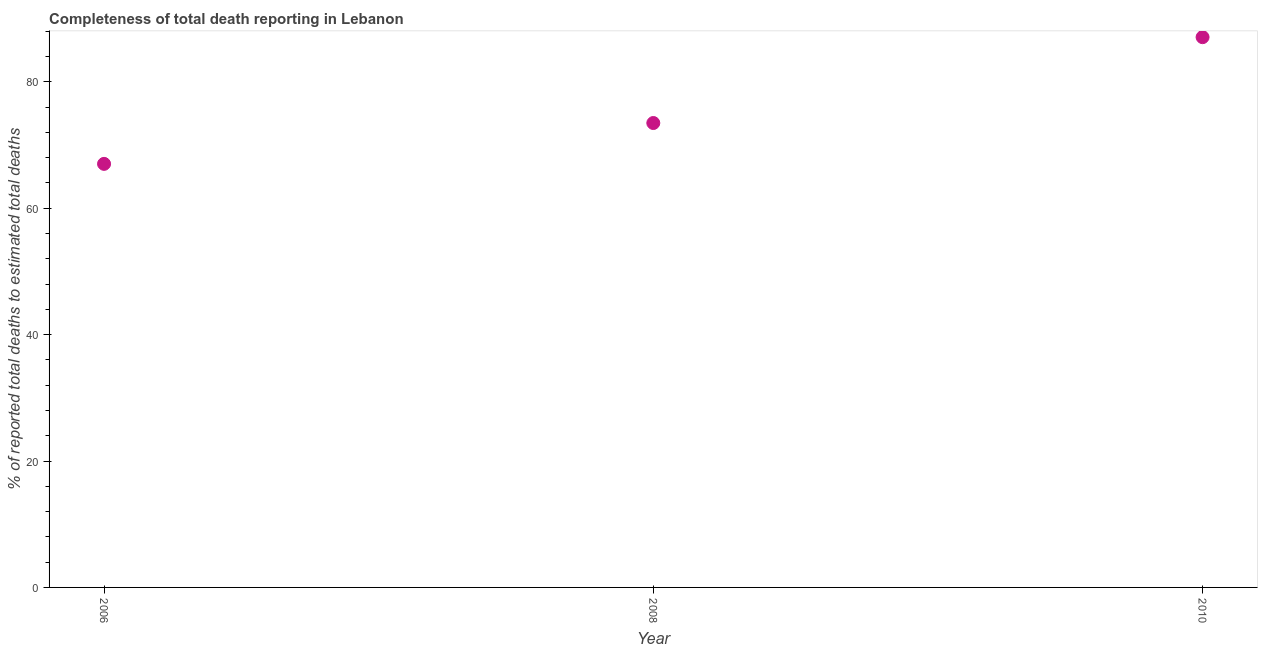What is the completeness of total death reports in 2010?
Provide a succinct answer. 87.08. Across all years, what is the maximum completeness of total death reports?
Offer a very short reply. 87.08. Across all years, what is the minimum completeness of total death reports?
Offer a terse response. 67.02. In which year was the completeness of total death reports maximum?
Make the answer very short. 2010. What is the sum of the completeness of total death reports?
Ensure brevity in your answer.  227.59. What is the difference between the completeness of total death reports in 2006 and 2010?
Provide a short and direct response. -20.05. What is the average completeness of total death reports per year?
Offer a terse response. 75.86. What is the median completeness of total death reports?
Keep it short and to the point. 73.49. In how many years, is the completeness of total death reports greater than 8 %?
Provide a succinct answer. 3. Do a majority of the years between 2006 and 2008 (inclusive) have completeness of total death reports greater than 40 %?
Offer a very short reply. Yes. What is the ratio of the completeness of total death reports in 2008 to that in 2010?
Ensure brevity in your answer.  0.84. Is the difference between the completeness of total death reports in 2008 and 2010 greater than the difference between any two years?
Give a very brief answer. No. What is the difference between the highest and the second highest completeness of total death reports?
Give a very brief answer. 13.59. Is the sum of the completeness of total death reports in 2006 and 2010 greater than the maximum completeness of total death reports across all years?
Offer a terse response. Yes. What is the difference between the highest and the lowest completeness of total death reports?
Ensure brevity in your answer.  20.05. Does the completeness of total death reports monotonically increase over the years?
Give a very brief answer. Yes. What is the difference between two consecutive major ticks on the Y-axis?
Provide a short and direct response. 20. Does the graph contain any zero values?
Give a very brief answer. No. What is the title of the graph?
Offer a terse response. Completeness of total death reporting in Lebanon. What is the label or title of the X-axis?
Your response must be concise. Year. What is the label or title of the Y-axis?
Keep it short and to the point. % of reported total deaths to estimated total deaths. What is the % of reported total deaths to estimated total deaths in 2006?
Give a very brief answer. 67.02. What is the % of reported total deaths to estimated total deaths in 2008?
Make the answer very short. 73.49. What is the % of reported total deaths to estimated total deaths in 2010?
Offer a terse response. 87.08. What is the difference between the % of reported total deaths to estimated total deaths in 2006 and 2008?
Give a very brief answer. -6.46. What is the difference between the % of reported total deaths to estimated total deaths in 2006 and 2010?
Provide a short and direct response. -20.05. What is the difference between the % of reported total deaths to estimated total deaths in 2008 and 2010?
Provide a short and direct response. -13.59. What is the ratio of the % of reported total deaths to estimated total deaths in 2006 to that in 2008?
Make the answer very short. 0.91. What is the ratio of the % of reported total deaths to estimated total deaths in 2006 to that in 2010?
Provide a short and direct response. 0.77. What is the ratio of the % of reported total deaths to estimated total deaths in 2008 to that in 2010?
Your response must be concise. 0.84. 